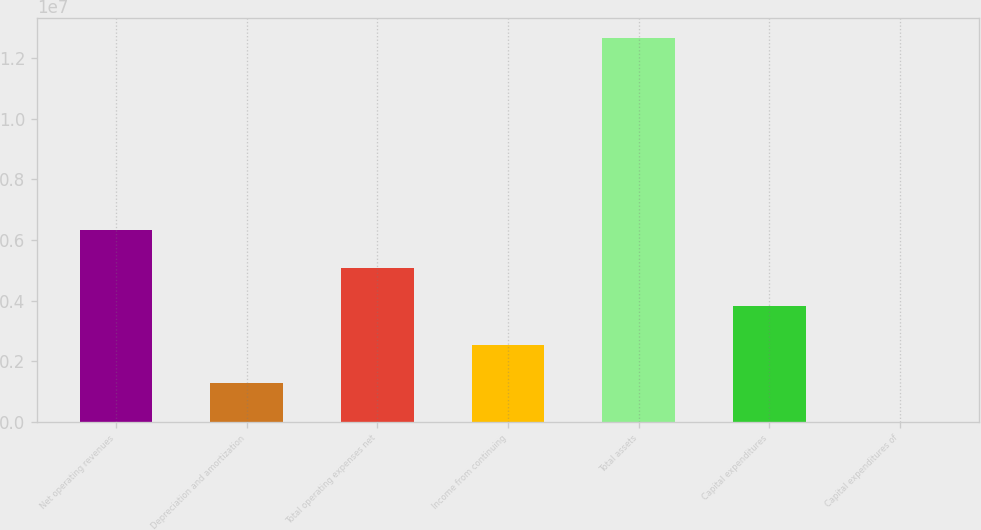Convert chart to OTSL. <chart><loc_0><loc_0><loc_500><loc_500><bar_chart><fcel>Net operating revenues<fcel>Depreciation and amortization<fcel>Total operating expenses net<fcel>Income from continuing<fcel>Total assets<fcel>Capital expenditures<fcel>Capital expenditures of<nl><fcel>6.34187e+06<fcel>1.27068e+06<fcel>5.07407e+06<fcel>2.53848e+06<fcel>1.26809e+07<fcel>3.80628e+06<fcel>2884<nl></chart> 